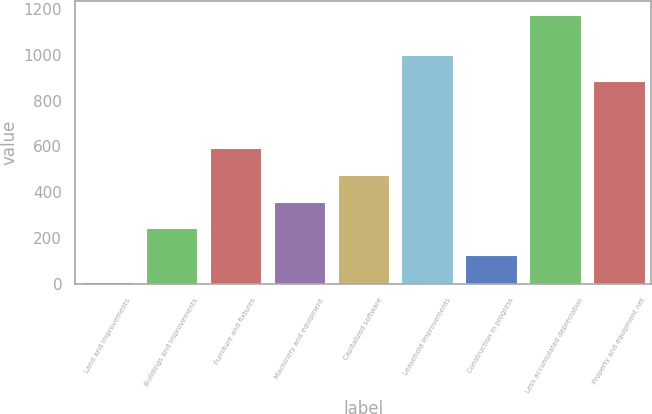Convert chart. <chart><loc_0><loc_0><loc_500><loc_500><bar_chart><fcel>Land and improvements<fcel>Buildings and improvements<fcel>Furniture and fixtures<fcel>Machinery and equipment<fcel>Capitalized software<fcel>Leasehold improvements<fcel>Construction in progress<fcel>Less accumulated depreciation<fcel>Property and equipment net<nl><fcel>9.9<fcel>242.8<fcel>592.15<fcel>359.25<fcel>475.7<fcel>1000.55<fcel>126.35<fcel>1174.4<fcel>884.1<nl></chart> 